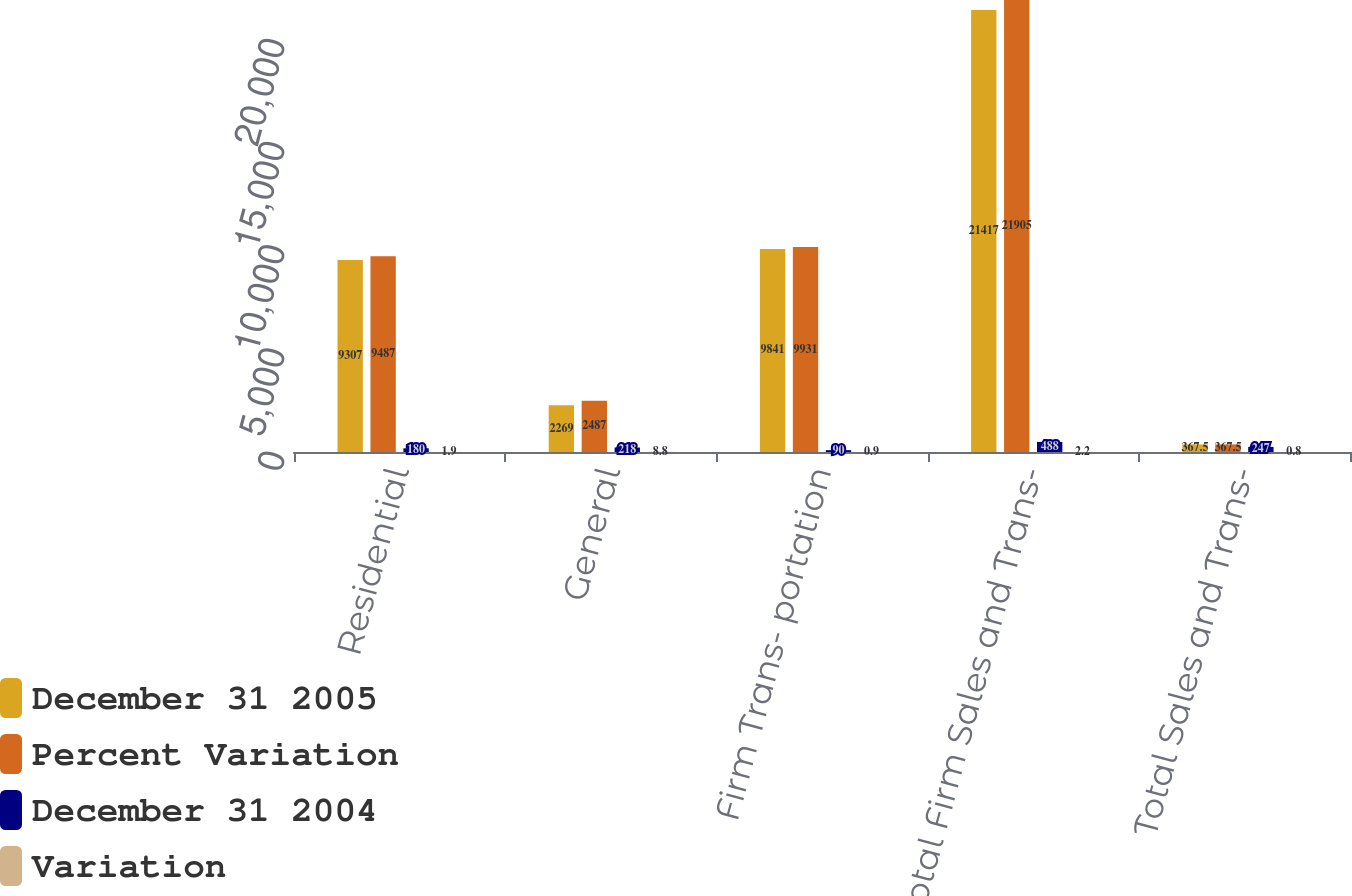Convert chart to OTSL. <chart><loc_0><loc_0><loc_500><loc_500><stacked_bar_chart><ecel><fcel>Residential<fcel>General<fcel>Firm Trans- portation<fcel>Total Firm Sales and Trans-<fcel>Total Sales and Trans-<nl><fcel>December 31 2005<fcel>9307<fcel>2269<fcel>9841<fcel>21417<fcel>367.5<nl><fcel>Percent Variation<fcel>9487<fcel>2487<fcel>9931<fcel>21905<fcel>367.5<nl><fcel>December 31 2004<fcel>180<fcel>218<fcel>90<fcel>488<fcel>247<nl><fcel>Variation<fcel>1.9<fcel>8.8<fcel>0.9<fcel>2.2<fcel>0.8<nl></chart> 